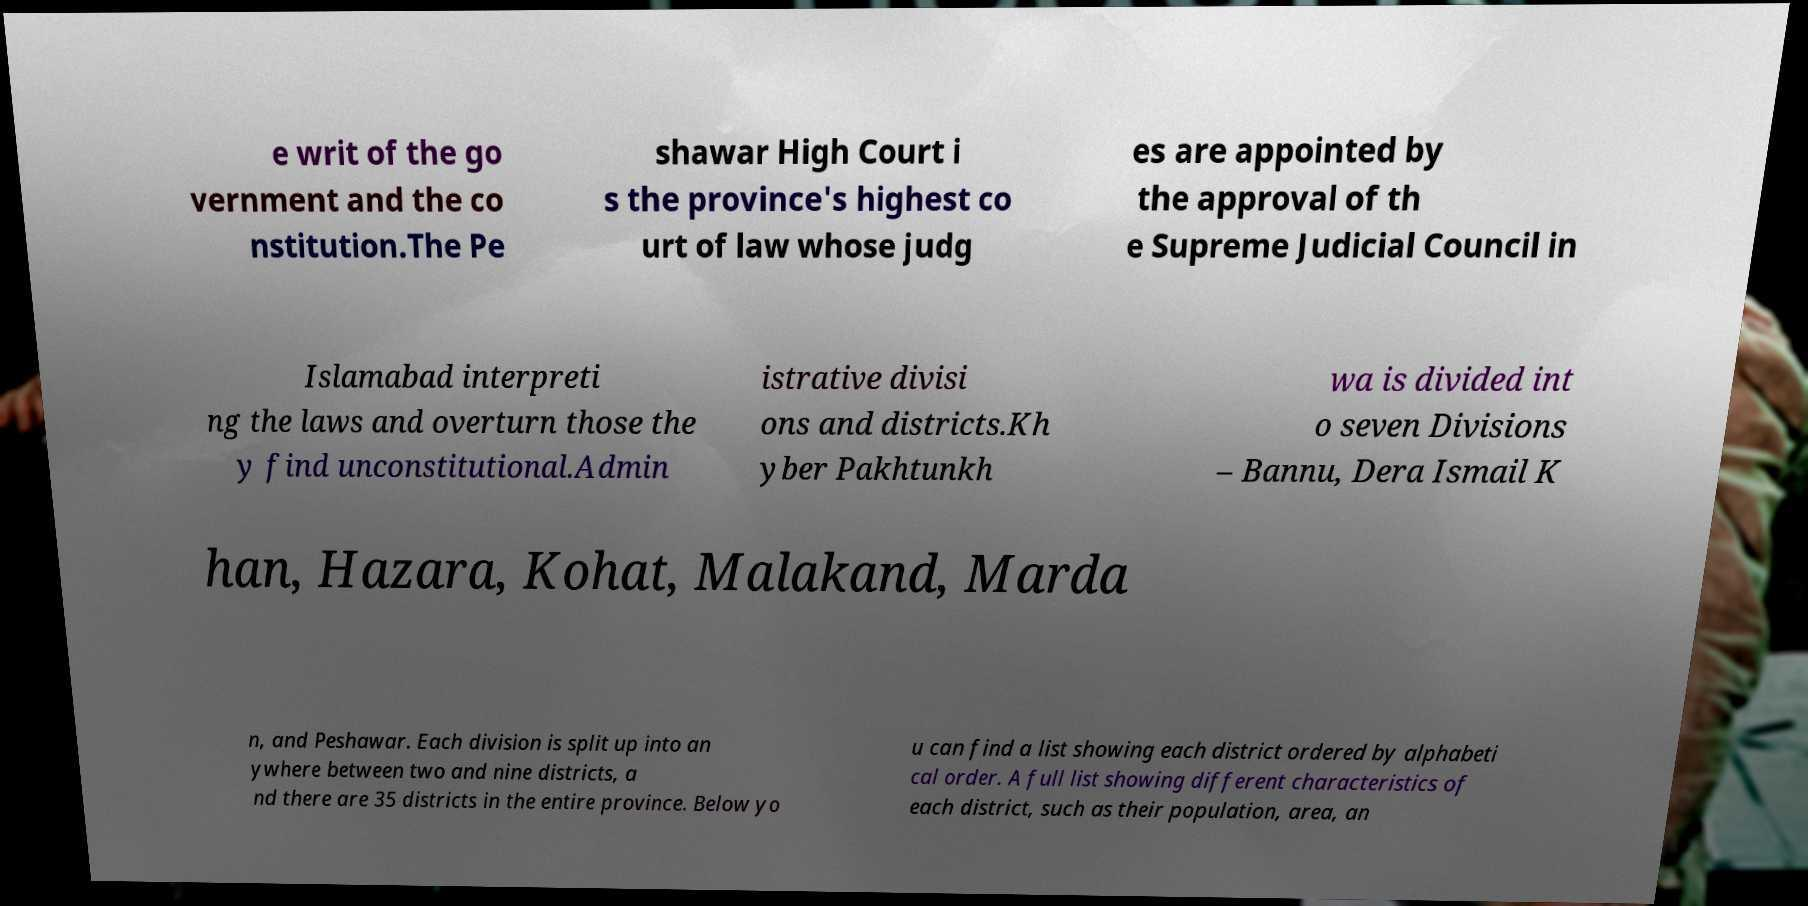Please identify and transcribe the text found in this image. e writ of the go vernment and the co nstitution.The Pe shawar High Court i s the province's highest co urt of law whose judg es are appointed by the approval of th e Supreme Judicial Council in Islamabad interpreti ng the laws and overturn those the y find unconstitutional.Admin istrative divisi ons and districts.Kh yber Pakhtunkh wa is divided int o seven Divisions – Bannu, Dera Ismail K han, Hazara, Kohat, Malakand, Marda n, and Peshawar. Each division is split up into an ywhere between two and nine districts, a nd there are 35 districts in the entire province. Below yo u can find a list showing each district ordered by alphabeti cal order. A full list showing different characteristics of each district, such as their population, area, an 